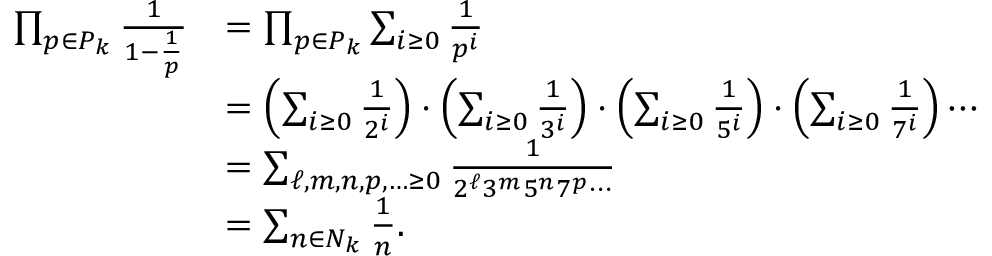<formula> <loc_0><loc_0><loc_500><loc_500>{ \begin{array} { r l } { \prod _ { p \in P _ { k } } { \frac { 1 } { 1 - { \frac { 1 } { p } } } } } & { = \prod _ { p \in P _ { k } } \sum _ { i \geq 0 } { \frac { 1 } { p ^ { i } } } } \\ & { = \left ( \sum _ { i \geq 0 } { \frac { 1 } { 2 ^ { i } } } \right ) \cdot \left ( \sum _ { i \geq 0 } { \frac { 1 } { 3 ^ { i } } } \right ) \cdot \left ( \sum _ { i \geq 0 } { \frac { 1 } { 5 ^ { i } } } \right ) \cdot \left ( \sum _ { i \geq 0 } { \frac { 1 } { 7 ^ { i } } } \right ) \cdots } \\ & { = \sum _ { \ell , m , n , p , \dots \geq 0 } { \frac { 1 } { 2 ^ { \ell } 3 ^ { m } 5 ^ { n } 7 ^ { p } \cdots } } } \\ & { = \sum _ { n \in N _ { k } } { \frac { 1 } { n } } . } \end{array} }</formula> 